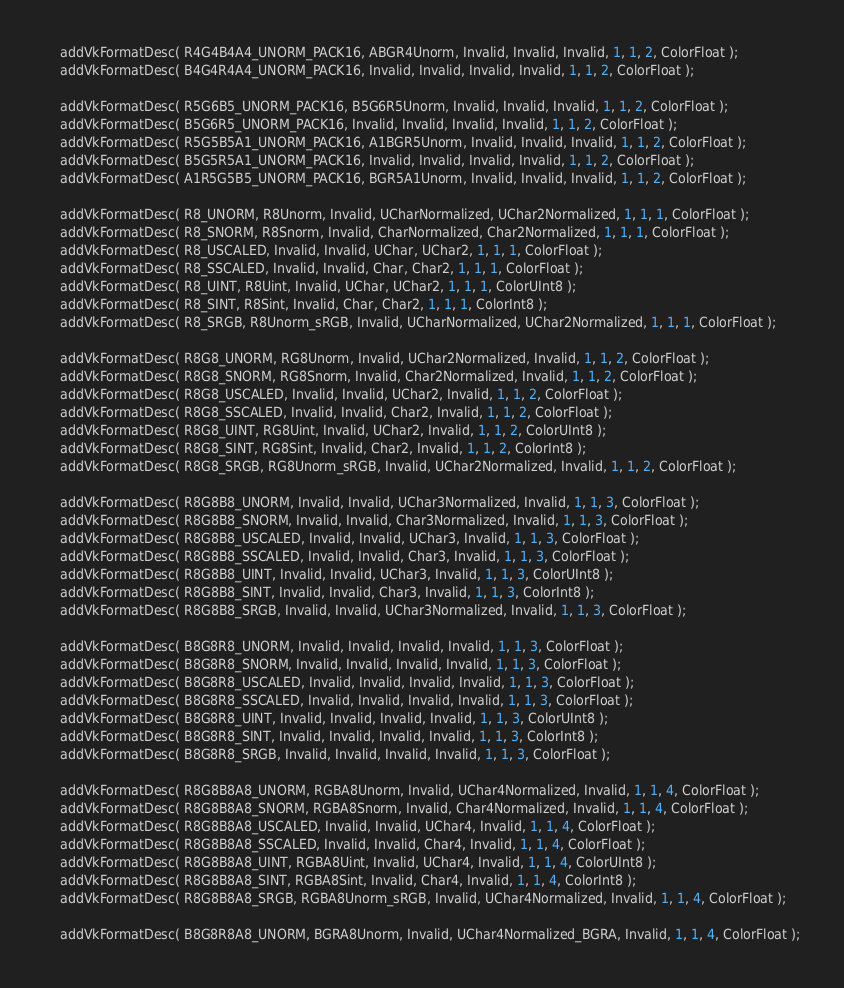Convert code to text. <code><loc_0><loc_0><loc_500><loc_500><_ObjectiveC_>	addVkFormatDesc( R4G4B4A4_UNORM_PACK16, ABGR4Unorm, Invalid, Invalid, Invalid, 1, 1, 2, ColorFloat );
	addVkFormatDesc( B4G4R4A4_UNORM_PACK16, Invalid, Invalid, Invalid, Invalid, 1, 1, 2, ColorFloat );

	addVkFormatDesc( R5G6B5_UNORM_PACK16, B5G6R5Unorm, Invalid, Invalid, Invalid, 1, 1, 2, ColorFloat );
	addVkFormatDesc( B5G6R5_UNORM_PACK16, Invalid, Invalid, Invalid, Invalid, 1, 1, 2, ColorFloat );
	addVkFormatDesc( R5G5B5A1_UNORM_PACK16, A1BGR5Unorm, Invalid, Invalid, Invalid, 1, 1, 2, ColorFloat );
	addVkFormatDesc( B5G5R5A1_UNORM_PACK16, Invalid, Invalid, Invalid, Invalid, 1, 1, 2, ColorFloat );
	addVkFormatDesc( A1R5G5B5_UNORM_PACK16, BGR5A1Unorm, Invalid, Invalid, Invalid, 1, 1, 2, ColorFloat );

	addVkFormatDesc( R8_UNORM, R8Unorm, Invalid, UCharNormalized, UChar2Normalized, 1, 1, 1, ColorFloat );
	addVkFormatDesc( R8_SNORM, R8Snorm, Invalid, CharNormalized, Char2Normalized, 1, 1, 1, ColorFloat );
	addVkFormatDesc( R8_USCALED, Invalid, Invalid, UChar, UChar2, 1, 1, 1, ColorFloat );
	addVkFormatDesc( R8_SSCALED, Invalid, Invalid, Char, Char2, 1, 1, 1, ColorFloat );
	addVkFormatDesc( R8_UINT, R8Uint, Invalid, UChar, UChar2, 1, 1, 1, ColorUInt8 );
	addVkFormatDesc( R8_SINT, R8Sint, Invalid, Char, Char2, 1, 1, 1, ColorInt8 );
	addVkFormatDesc( R8_SRGB, R8Unorm_sRGB, Invalid, UCharNormalized, UChar2Normalized, 1, 1, 1, ColorFloat );

	addVkFormatDesc( R8G8_UNORM, RG8Unorm, Invalid, UChar2Normalized, Invalid, 1, 1, 2, ColorFloat );
	addVkFormatDesc( R8G8_SNORM, RG8Snorm, Invalid, Char2Normalized, Invalid, 1, 1, 2, ColorFloat );
	addVkFormatDesc( R8G8_USCALED, Invalid, Invalid, UChar2, Invalid, 1, 1, 2, ColorFloat );
	addVkFormatDesc( R8G8_SSCALED, Invalid, Invalid, Char2, Invalid, 1, 1, 2, ColorFloat );
	addVkFormatDesc( R8G8_UINT, RG8Uint, Invalid, UChar2, Invalid, 1, 1, 2, ColorUInt8 );
	addVkFormatDesc( R8G8_SINT, RG8Sint, Invalid, Char2, Invalid, 1, 1, 2, ColorInt8 );
	addVkFormatDesc( R8G8_SRGB, RG8Unorm_sRGB, Invalid, UChar2Normalized, Invalid, 1, 1, 2, ColorFloat );

	addVkFormatDesc( R8G8B8_UNORM, Invalid, Invalid, UChar3Normalized, Invalid, 1, 1, 3, ColorFloat );
	addVkFormatDesc( R8G8B8_SNORM, Invalid, Invalid, Char3Normalized, Invalid, 1, 1, 3, ColorFloat );
	addVkFormatDesc( R8G8B8_USCALED, Invalid, Invalid, UChar3, Invalid, 1, 1, 3, ColorFloat );
	addVkFormatDesc( R8G8B8_SSCALED, Invalid, Invalid, Char3, Invalid, 1, 1, 3, ColorFloat );
	addVkFormatDesc( R8G8B8_UINT, Invalid, Invalid, UChar3, Invalid, 1, 1, 3, ColorUInt8 );
	addVkFormatDesc( R8G8B8_SINT, Invalid, Invalid, Char3, Invalid, 1, 1, 3, ColorInt8 );
	addVkFormatDesc( R8G8B8_SRGB, Invalid, Invalid, UChar3Normalized, Invalid, 1, 1, 3, ColorFloat );

	addVkFormatDesc( B8G8R8_UNORM, Invalid, Invalid, Invalid, Invalid, 1, 1, 3, ColorFloat );
	addVkFormatDesc( B8G8R8_SNORM, Invalid, Invalid, Invalid, Invalid, 1, 1, 3, ColorFloat );
	addVkFormatDesc( B8G8R8_USCALED, Invalid, Invalid, Invalid, Invalid, 1, 1, 3, ColorFloat );
	addVkFormatDesc( B8G8R8_SSCALED, Invalid, Invalid, Invalid, Invalid, 1, 1, 3, ColorFloat );
	addVkFormatDesc( B8G8R8_UINT, Invalid, Invalid, Invalid, Invalid, 1, 1, 3, ColorUInt8 );
	addVkFormatDesc( B8G8R8_SINT, Invalid, Invalid, Invalid, Invalid, 1, 1, 3, ColorInt8 );
	addVkFormatDesc( B8G8R8_SRGB, Invalid, Invalid, Invalid, Invalid, 1, 1, 3, ColorFloat );

	addVkFormatDesc( R8G8B8A8_UNORM, RGBA8Unorm, Invalid, UChar4Normalized, Invalid, 1, 1, 4, ColorFloat );
	addVkFormatDesc( R8G8B8A8_SNORM, RGBA8Snorm, Invalid, Char4Normalized, Invalid, 1, 1, 4, ColorFloat );
	addVkFormatDesc( R8G8B8A8_USCALED, Invalid, Invalid, UChar4, Invalid, 1, 1, 4, ColorFloat );
	addVkFormatDesc( R8G8B8A8_SSCALED, Invalid, Invalid, Char4, Invalid, 1, 1, 4, ColorFloat );
	addVkFormatDesc( R8G8B8A8_UINT, RGBA8Uint, Invalid, UChar4, Invalid, 1, 1, 4, ColorUInt8 );
	addVkFormatDesc( R8G8B8A8_SINT, RGBA8Sint, Invalid, Char4, Invalid, 1, 1, 4, ColorInt8 );
	addVkFormatDesc( R8G8B8A8_SRGB, RGBA8Unorm_sRGB, Invalid, UChar4Normalized, Invalid, 1, 1, 4, ColorFloat );

	addVkFormatDesc( B8G8R8A8_UNORM, BGRA8Unorm, Invalid, UChar4Normalized_BGRA, Invalid, 1, 1, 4, ColorFloat );</code> 